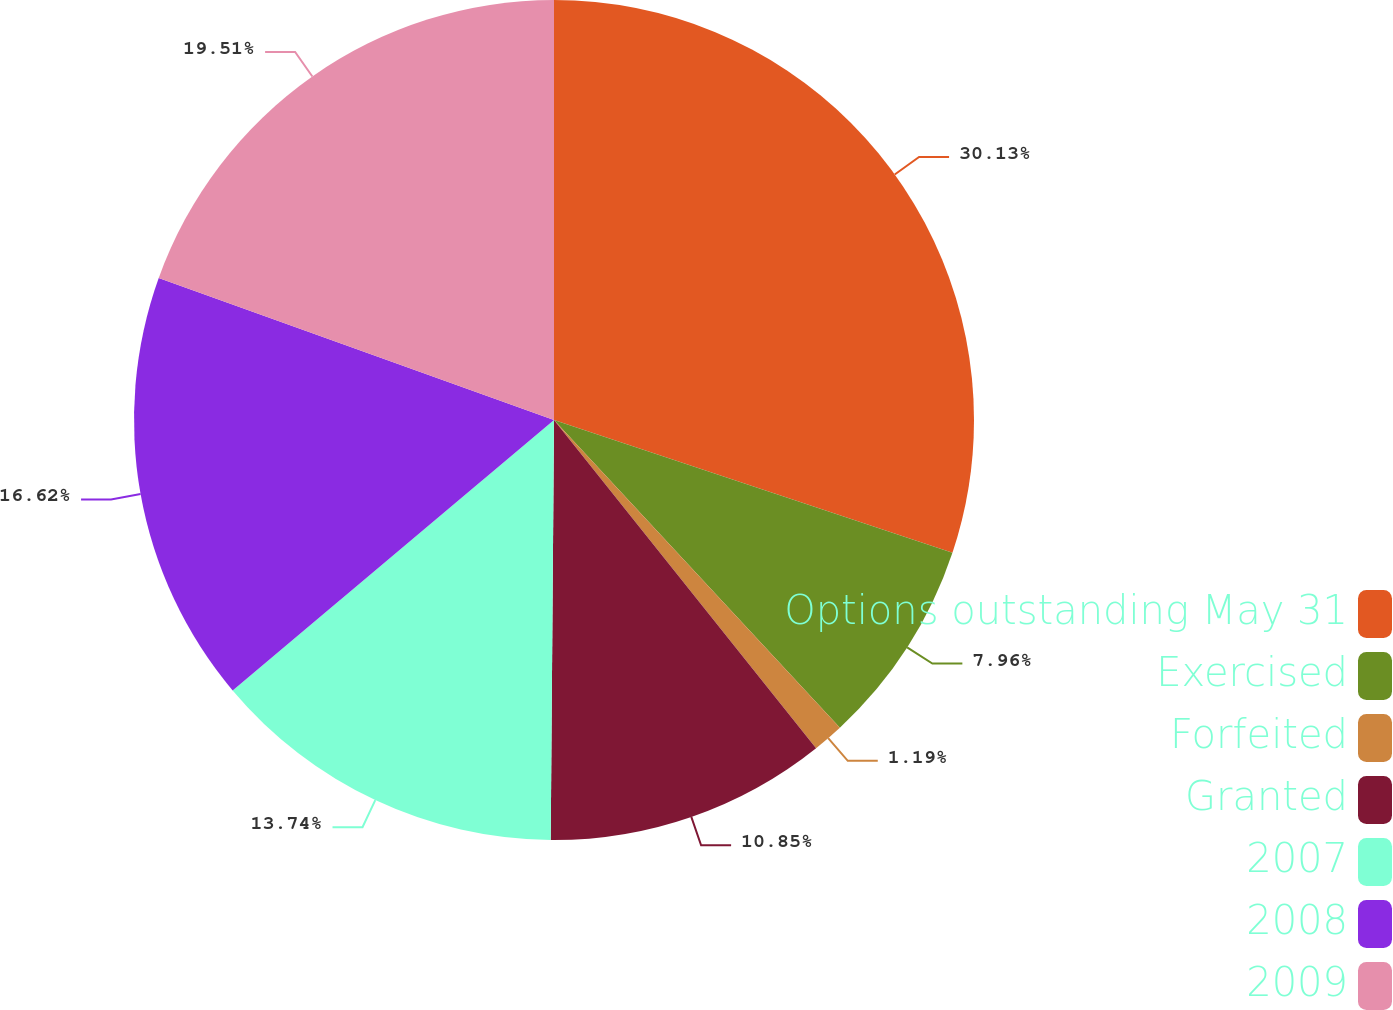<chart> <loc_0><loc_0><loc_500><loc_500><pie_chart><fcel>Options outstanding May 31<fcel>Exercised<fcel>Forfeited<fcel>Granted<fcel>2007<fcel>2008<fcel>2009<nl><fcel>30.12%<fcel>7.96%<fcel>1.19%<fcel>10.85%<fcel>13.74%<fcel>16.62%<fcel>19.51%<nl></chart> 